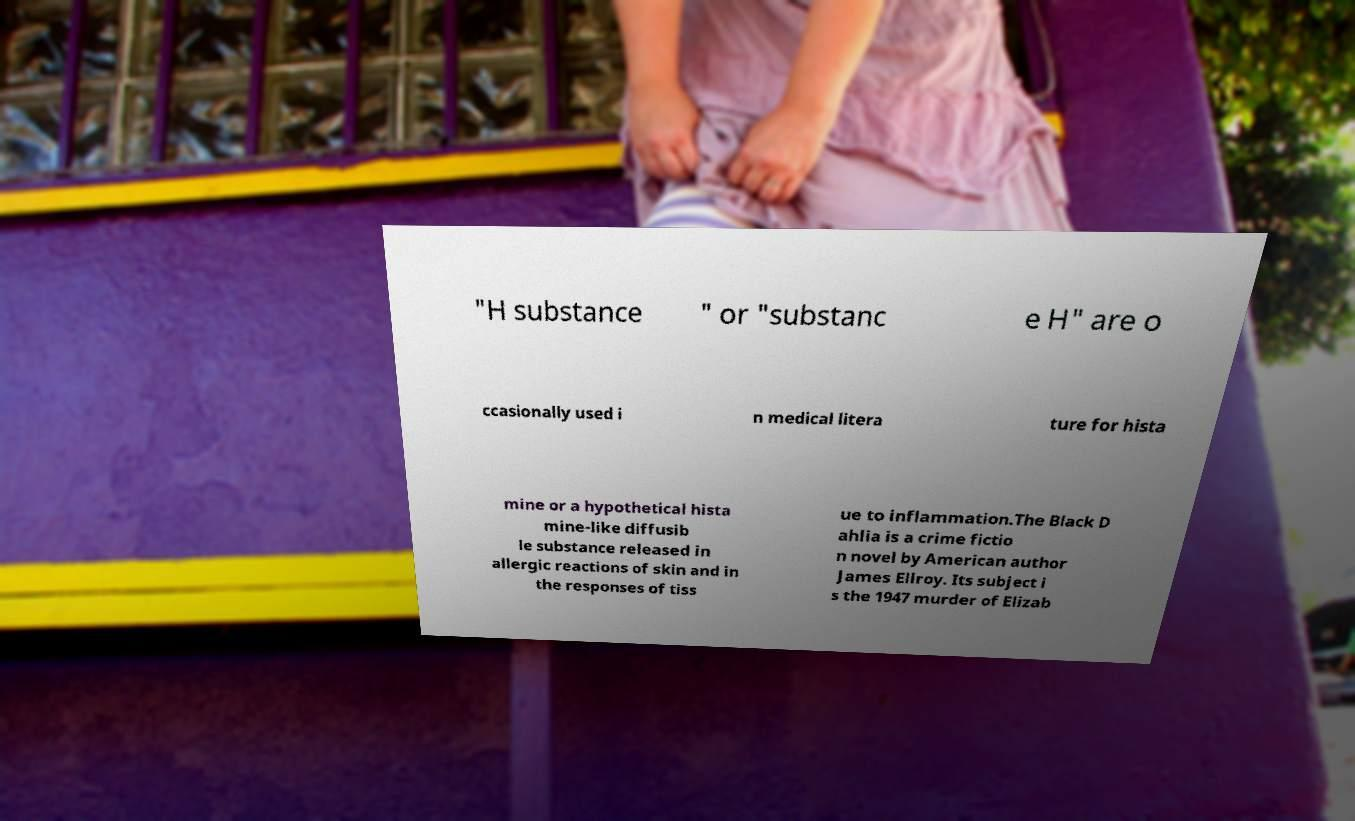Please read and relay the text visible in this image. What does it say? "H substance " or "substanc e H" are o ccasionally used i n medical litera ture for hista mine or a hypothetical hista mine-like diffusib le substance released in allergic reactions of skin and in the responses of tiss ue to inflammation.The Black D ahlia is a crime fictio n novel by American author James Ellroy. Its subject i s the 1947 murder of Elizab 